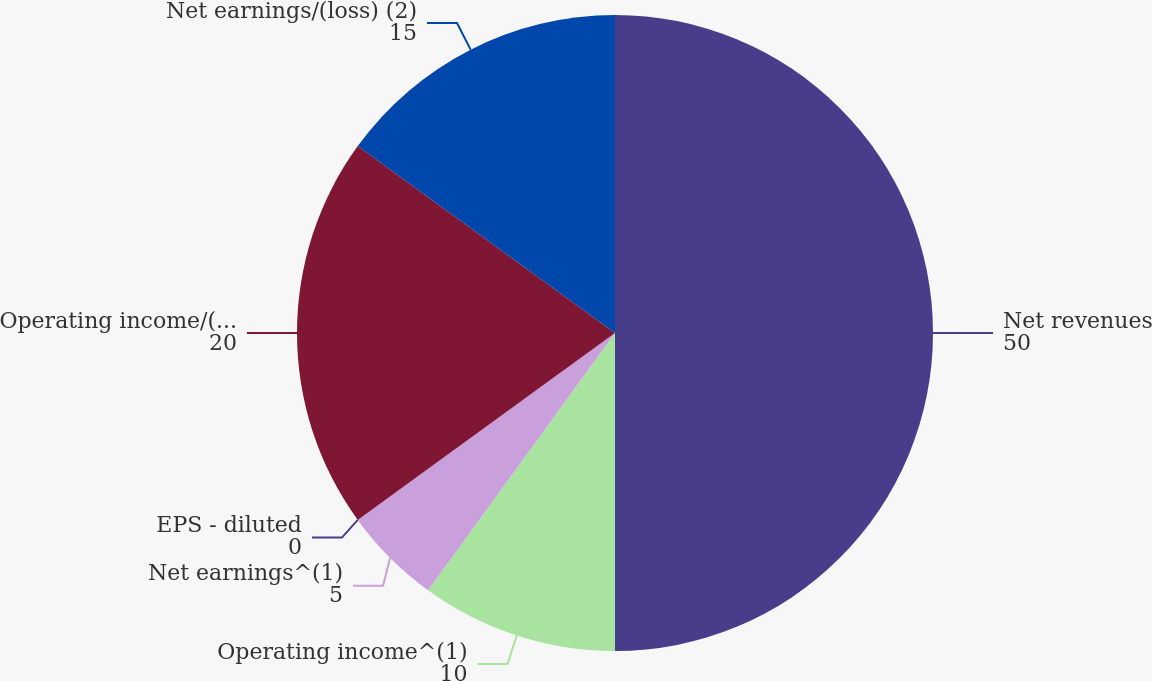Convert chart to OTSL. <chart><loc_0><loc_0><loc_500><loc_500><pie_chart><fcel>Net revenues<fcel>Operating income^(1)<fcel>Net earnings^(1)<fcel>EPS - diluted<fcel>Operating income/(loss) (2)<fcel>Net earnings/(loss) (2)<nl><fcel>50.0%<fcel>10.0%<fcel>5.0%<fcel>0.0%<fcel>20.0%<fcel>15.0%<nl></chart> 